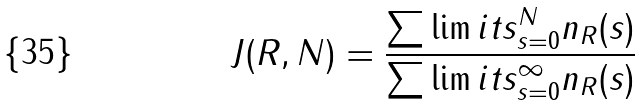Convert formula to latex. <formula><loc_0><loc_0><loc_500><loc_500>J ( R , N ) = \frac { \sum \lim i t s _ { s = 0 } ^ { N } n _ { R } ( s ) } { \sum \lim i t s _ { s = 0 } ^ { \infty } n _ { R } ( s ) }</formula> 